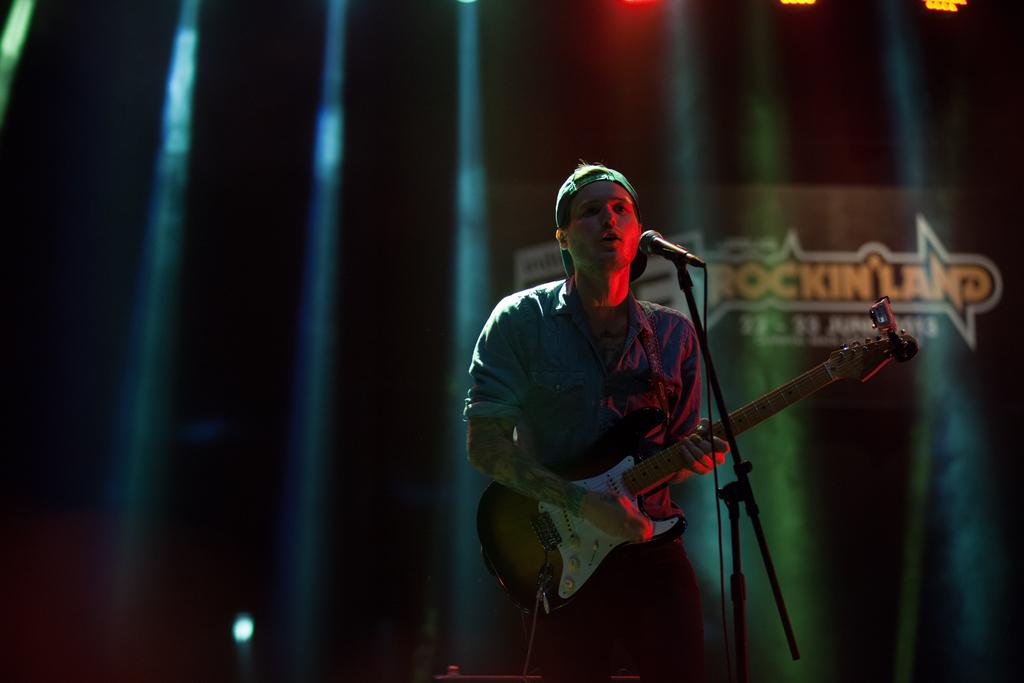What is the man in the image doing? The man is standing, playing the guitar, and singing into a microphone. What is the man wearing on his head? The man is wearing a cap. What is the man wearing on his upper body? The man is wearing a shirt. What can be seen on the right side of the image? There is a name in yellow color on the right side of the image. What type of vessel can be seen sailing in the background of the image? There is no vessel visible in the image; it features a man playing the guitar, singing, and wearing a cap and shirt. 